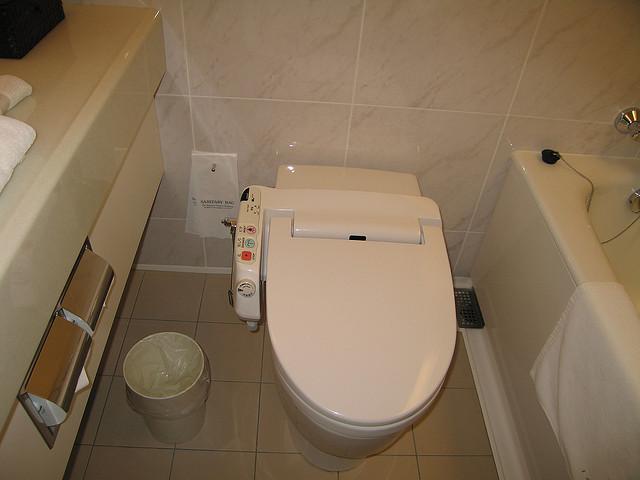Is the trash can full?
Keep it brief. No. What color is the tissue roll?
Write a very short answer. White. What color is the toilet?
Keep it brief. White. Is the toilet seat up?
Write a very short answer. No. 